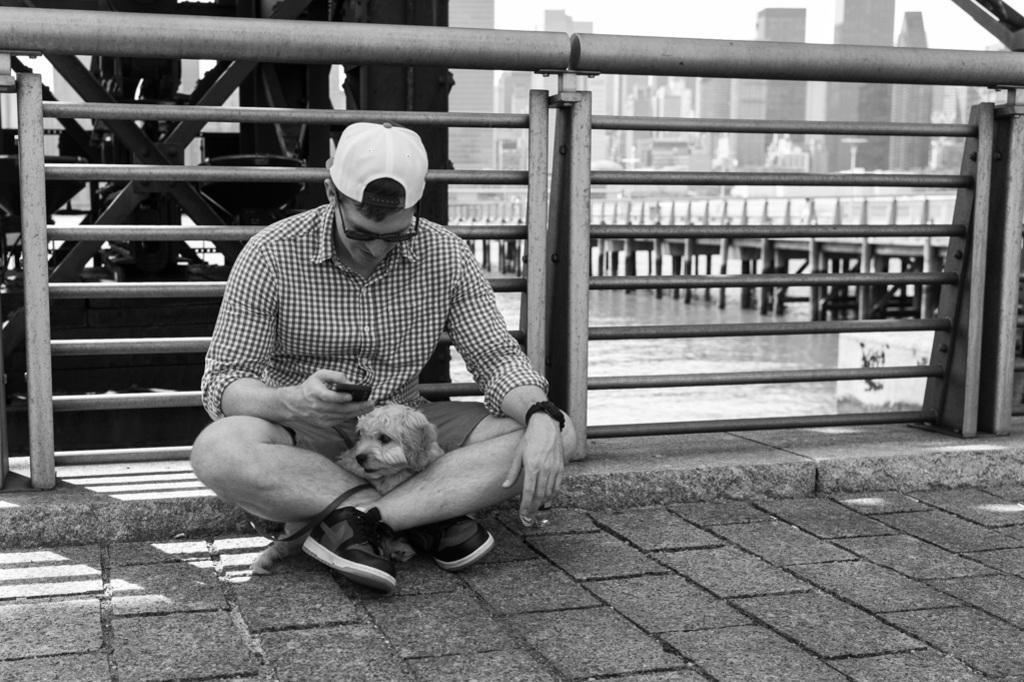Can you describe this image briefly? a person is sitting on a road. there is a dog near to him. behind him there is a fencing, water, bridge and buildings. 